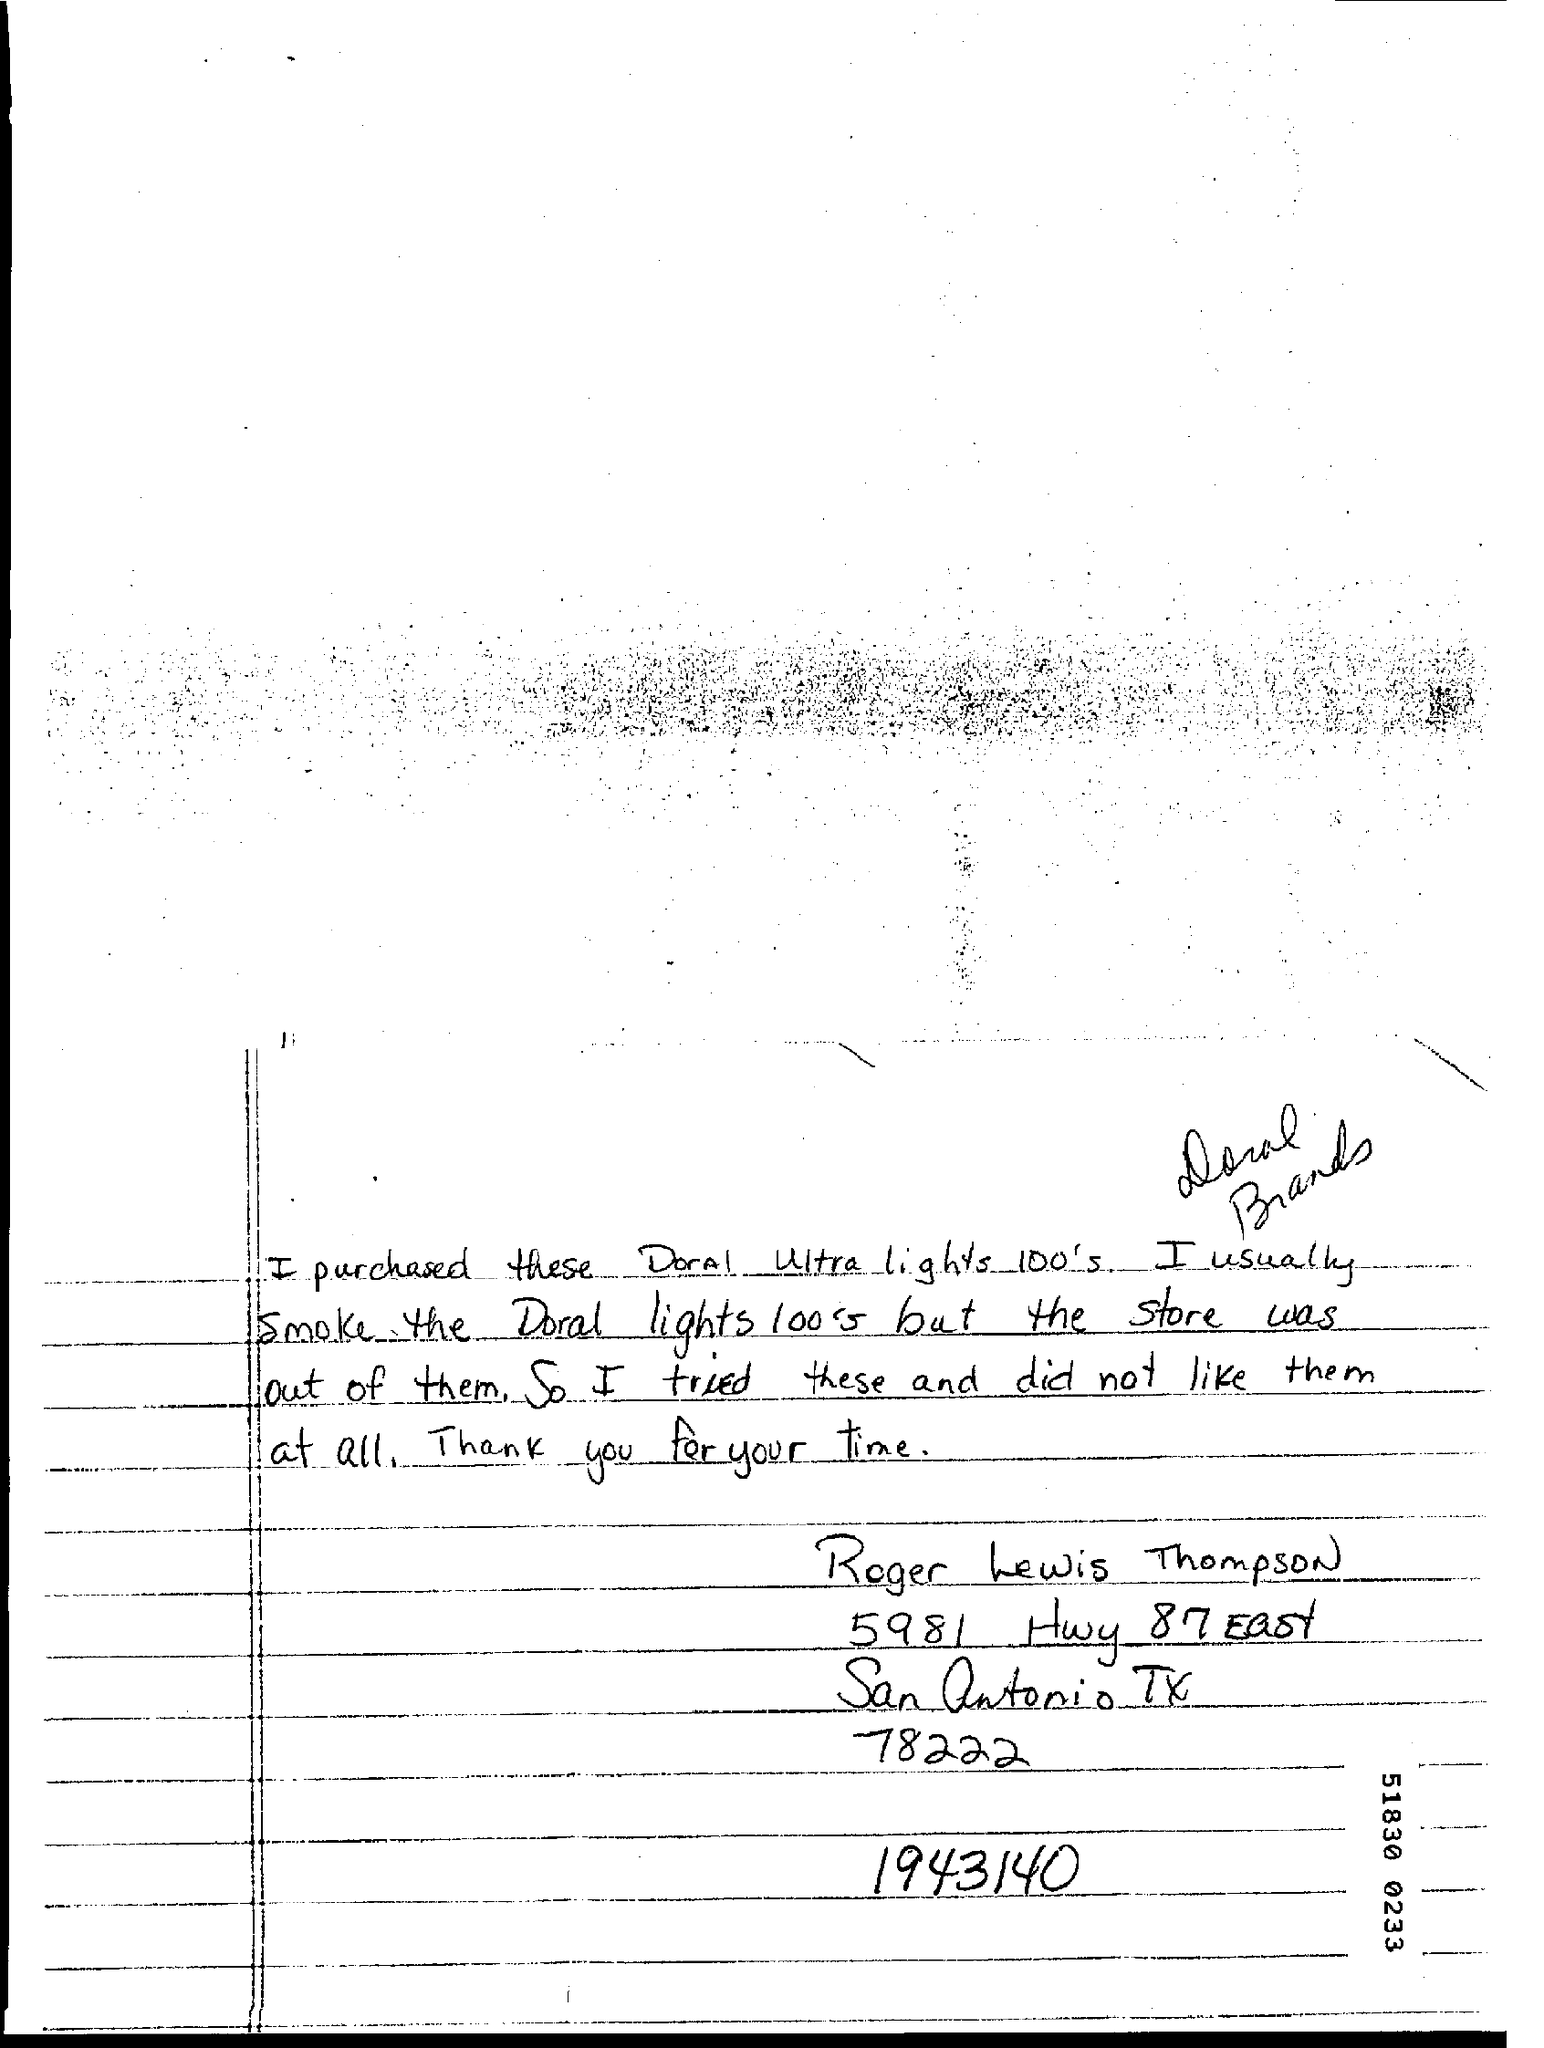Indicate a few pertinent items in this graphic. The complaint was written by Roger Lewis Thompson. Roger tried a different product because his usual brand was not available, and that product was Doral Ultra lights 100's. Roger usually uses Doral lights 100's brand. 